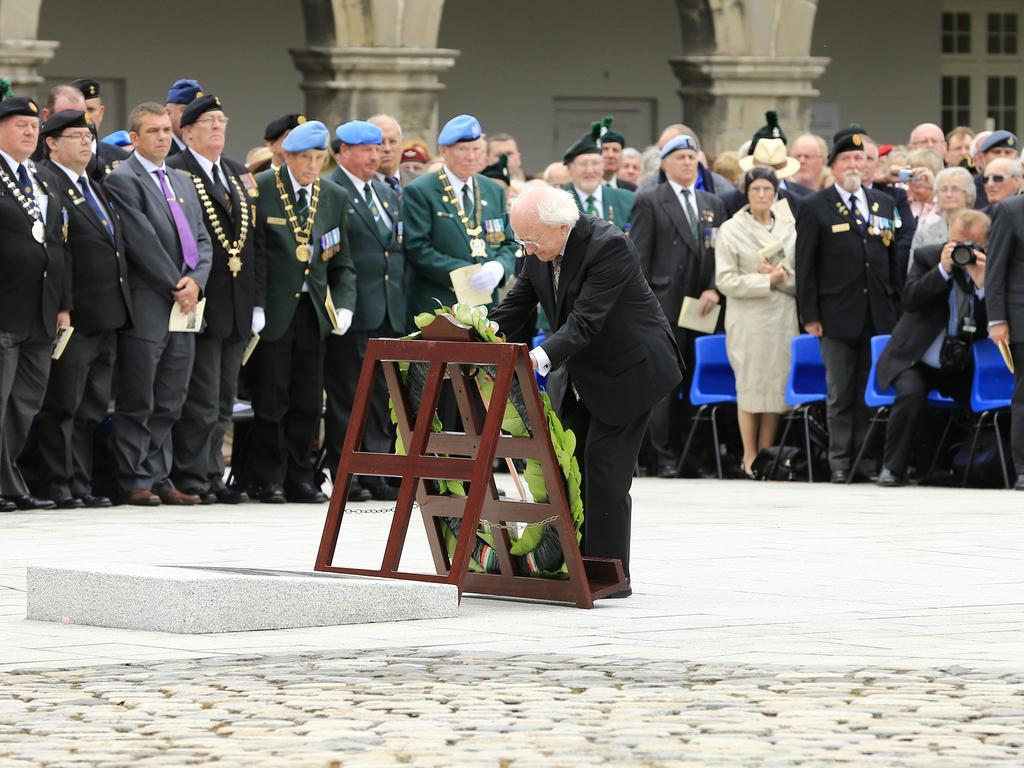Describe this image in one or two sentences. At the bottom of the image, we can see a pavement. In the middle of the image, we can see a man is standing. In front of the man, we can see a wooden object with garland. In the background, we can see so many men and women are standing. On the right side of the image, we can see chairs and one man is holding a camera in his hand. At the top of the image, we can see pillars, wall, doors and a window. 